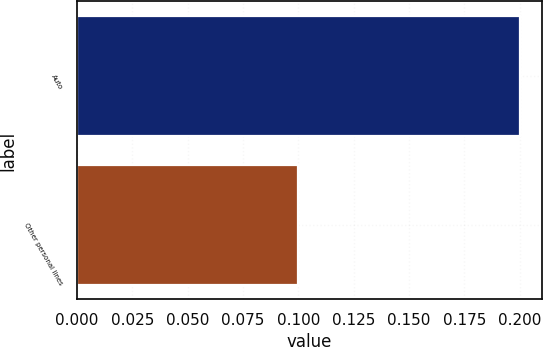Convert chart to OTSL. <chart><loc_0><loc_0><loc_500><loc_500><bar_chart><fcel>Auto<fcel>Other personal lines<nl><fcel>0.2<fcel>0.1<nl></chart> 